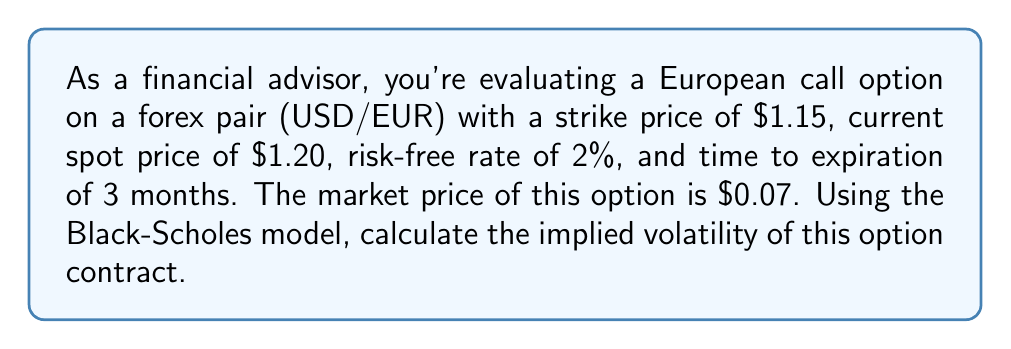Can you answer this question? To calculate the implied volatility, we need to use the Black-Scholes model and solve for the volatility parameter that makes the theoretical price equal to the market price. We'll use an iterative approach:

1. Black-Scholes formula for a European call option:
   $$C = S_0N(d_1) - Ke^{-rT}N(d_2)$$
   Where:
   $$d_1 = \frac{\ln(S_0/K) + (r + \sigma^2/2)T}{\sigma\sqrt{T}}$$
   $$d_2 = d_1 - \sigma\sqrt{T}$$

2. Given parameters:
   $S_0 = 1.20$ (current spot price)
   $K = 1.15$ (strike price)
   $r = 0.02$ (risk-free rate)
   $T = 0.25$ (3 months = 0.25 years)
   $C = 0.07$ (market price of the option)

3. We'll use the Newton-Raphson method to find the implied volatility:
   $$\sigma_{n+1} = \sigma_n - \frac{C(\sigma_n) - C_{market}}{vega(\sigma_n)}$$

4. Start with an initial guess, e.g., $\sigma_0 = 0.2$

5. Calculate $C(\sigma_0)$ using the Black-Scholes formula

6. Calculate vega:
   $$vega = S_0\sqrt{T}N'(d_1)$$

7. Update $\sigma$ using the Newton-Raphson formula

8. Repeat steps 5-7 until the difference between $C(\sigma_n)$ and $C_{market}$ is sufficiently small (e.g., < 0.0001)

After several iterations, we find that the implied volatility converges to approximately 0.1823 or 18.23%.
Answer: 18.23% 